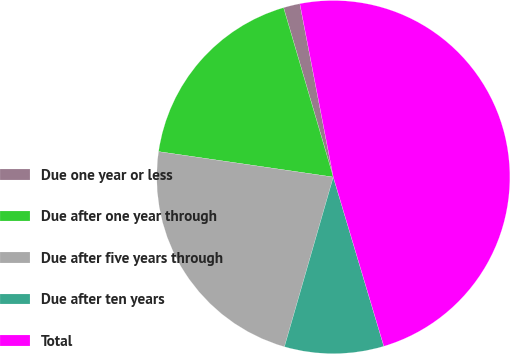Convert chart to OTSL. <chart><loc_0><loc_0><loc_500><loc_500><pie_chart><fcel>Due one year or less<fcel>Due after one year through<fcel>Due after five years through<fcel>Due after ten years<fcel>Total<nl><fcel>1.51%<fcel>18.15%<fcel>22.84%<fcel>9.08%<fcel>48.41%<nl></chart> 